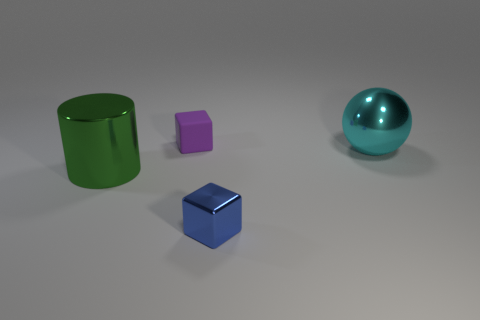Are there any other things that are made of the same material as the tiny purple object?
Provide a succinct answer. No. How many large objects are shiny blocks or cubes?
Your answer should be very brief. 0. There is a tiny thing behind the object on the right side of the cube in front of the big green cylinder; what is it made of?
Offer a very short reply. Rubber. How many metal objects are objects or big cyan objects?
Provide a succinct answer. 3. What number of brown things are small blocks or metal objects?
Your answer should be very brief. 0. Does the big cylinder have the same material as the tiny purple object?
Ensure brevity in your answer.  No. Are there the same number of big cyan things in front of the big cyan ball and big green metallic cylinders that are behind the blue block?
Provide a succinct answer. No. What is the material of the other tiny object that is the same shape as the purple object?
Your answer should be very brief. Metal. What shape is the small object that is in front of the large cyan metal sphere that is in front of the purple block behind the tiny blue object?
Provide a succinct answer. Cube. Is the number of things in front of the metal cylinder greater than the number of small purple metal balls?
Make the answer very short. Yes. 